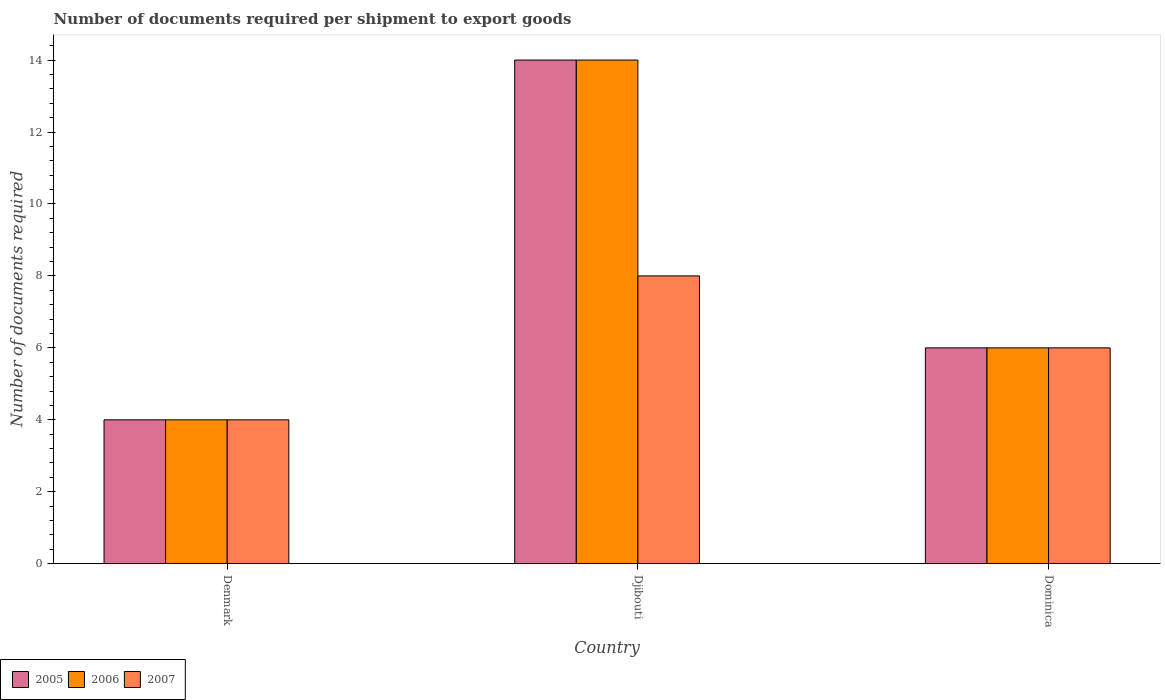How many different coloured bars are there?
Provide a short and direct response. 3. How many groups of bars are there?
Your response must be concise. 3. What is the label of the 2nd group of bars from the left?
Offer a very short reply. Djibouti. In how many cases, is the number of bars for a given country not equal to the number of legend labels?
Your answer should be very brief. 0. What is the number of documents required per shipment to export goods in 2005 in Djibouti?
Make the answer very short. 14. In which country was the number of documents required per shipment to export goods in 2007 maximum?
Your response must be concise. Djibouti. What is the difference between the number of documents required per shipment to export goods in 2007 in Denmark and that in Dominica?
Make the answer very short. -2. What is the difference between the number of documents required per shipment to export goods in 2007 in Djibouti and the number of documents required per shipment to export goods in 2006 in Dominica?
Your answer should be compact. 2. What is the average number of documents required per shipment to export goods in 2005 per country?
Provide a succinct answer. 8. What is the difference between the number of documents required per shipment to export goods of/in 2006 and number of documents required per shipment to export goods of/in 2007 in Djibouti?
Ensure brevity in your answer.  6. In how many countries, is the number of documents required per shipment to export goods in 2006 greater than 5.6?
Keep it short and to the point. 2. What is the difference between the highest and the second highest number of documents required per shipment to export goods in 2007?
Offer a very short reply. 4. What is the difference between the highest and the lowest number of documents required per shipment to export goods in 2007?
Your answer should be compact. 4. In how many countries, is the number of documents required per shipment to export goods in 2005 greater than the average number of documents required per shipment to export goods in 2005 taken over all countries?
Give a very brief answer. 1. Is the sum of the number of documents required per shipment to export goods in 2005 in Djibouti and Dominica greater than the maximum number of documents required per shipment to export goods in 2006 across all countries?
Provide a short and direct response. Yes. What does the 1st bar from the left in Dominica represents?
Ensure brevity in your answer.  2005. What does the 2nd bar from the right in Dominica represents?
Your answer should be very brief. 2006. Is it the case that in every country, the sum of the number of documents required per shipment to export goods in 2005 and number of documents required per shipment to export goods in 2006 is greater than the number of documents required per shipment to export goods in 2007?
Give a very brief answer. Yes. Are all the bars in the graph horizontal?
Ensure brevity in your answer.  No. What is the difference between two consecutive major ticks on the Y-axis?
Your response must be concise. 2. Are the values on the major ticks of Y-axis written in scientific E-notation?
Offer a very short reply. No. Does the graph contain any zero values?
Your response must be concise. No. Where does the legend appear in the graph?
Your response must be concise. Bottom left. How are the legend labels stacked?
Your answer should be compact. Horizontal. What is the title of the graph?
Your answer should be very brief. Number of documents required per shipment to export goods. What is the label or title of the Y-axis?
Provide a short and direct response. Number of documents required. What is the Number of documents required of 2005 in Djibouti?
Provide a short and direct response. 14. What is the Number of documents required in 2005 in Dominica?
Provide a succinct answer. 6. What is the Number of documents required in 2006 in Dominica?
Provide a short and direct response. 6. What is the Number of documents required in 2007 in Dominica?
Provide a succinct answer. 6. Across all countries, what is the maximum Number of documents required in 2005?
Provide a short and direct response. 14. Across all countries, what is the maximum Number of documents required of 2006?
Provide a short and direct response. 14. Across all countries, what is the maximum Number of documents required of 2007?
Ensure brevity in your answer.  8. Across all countries, what is the minimum Number of documents required of 2005?
Ensure brevity in your answer.  4. Across all countries, what is the minimum Number of documents required of 2006?
Keep it short and to the point. 4. What is the total Number of documents required of 2006 in the graph?
Provide a short and direct response. 24. What is the total Number of documents required of 2007 in the graph?
Make the answer very short. 18. What is the difference between the Number of documents required in 2005 in Denmark and that in Djibouti?
Offer a very short reply. -10. What is the difference between the Number of documents required of 2006 in Denmark and that in Djibouti?
Make the answer very short. -10. What is the difference between the Number of documents required in 2007 in Denmark and that in Djibouti?
Your answer should be compact. -4. What is the difference between the Number of documents required of 2006 in Denmark and that in Dominica?
Provide a succinct answer. -2. What is the difference between the Number of documents required of 2006 in Djibouti and that in Dominica?
Your answer should be very brief. 8. What is the difference between the Number of documents required of 2006 in Denmark and the Number of documents required of 2007 in Djibouti?
Your response must be concise. -4. What is the difference between the Number of documents required in 2005 in Denmark and the Number of documents required in 2006 in Dominica?
Make the answer very short. -2. What is the difference between the Number of documents required in 2005 in Denmark and the Number of documents required in 2007 in Dominica?
Provide a short and direct response. -2. What is the difference between the Number of documents required of 2006 in Denmark and the Number of documents required of 2007 in Dominica?
Provide a succinct answer. -2. What is the average Number of documents required of 2007 per country?
Offer a very short reply. 6. What is the difference between the Number of documents required of 2005 and Number of documents required of 2006 in Denmark?
Give a very brief answer. 0. What is the difference between the Number of documents required of 2005 and Number of documents required of 2006 in Djibouti?
Your answer should be very brief. 0. What is the difference between the Number of documents required in 2005 and Number of documents required in 2007 in Djibouti?
Give a very brief answer. 6. What is the difference between the Number of documents required of 2006 and Number of documents required of 2007 in Djibouti?
Ensure brevity in your answer.  6. What is the difference between the Number of documents required in 2005 and Number of documents required in 2007 in Dominica?
Make the answer very short. 0. What is the ratio of the Number of documents required in 2005 in Denmark to that in Djibouti?
Provide a succinct answer. 0.29. What is the ratio of the Number of documents required in 2006 in Denmark to that in Djibouti?
Keep it short and to the point. 0.29. What is the ratio of the Number of documents required of 2007 in Denmark to that in Djibouti?
Ensure brevity in your answer.  0.5. What is the ratio of the Number of documents required in 2006 in Denmark to that in Dominica?
Your answer should be compact. 0.67. What is the ratio of the Number of documents required in 2007 in Denmark to that in Dominica?
Make the answer very short. 0.67. What is the ratio of the Number of documents required in 2005 in Djibouti to that in Dominica?
Offer a very short reply. 2.33. What is the ratio of the Number of documents required of 2006 in Djibouti to that in Dominica?
Give a very brief answer. 2.33. What is the ratio of the Number of documents required of 2007 in Djibouti to that in Dominica?
Offer a terse response. 1.33. What is the difference between the highest and the second highest Number of documents required of 2006?
Keep it short and to the point. 8. What is the difference between the highest and the second highest Number of documents required of 2007?
Give a very brief answer. 2. What is the difference between the highest and the lowest Number of documents required in 2007?
Provide a short and direct response. 4. 